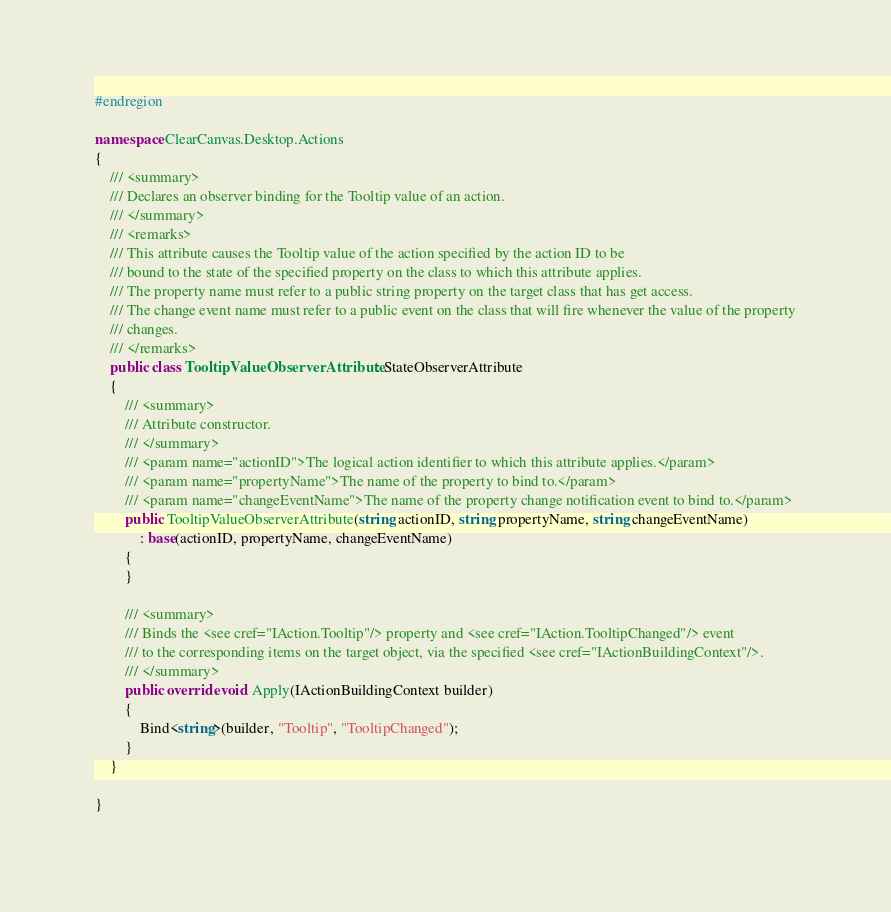Convert code to text. <code><loc_0><loc_0><loc_500><loc_500><_C#_>
#endregion

namespace ClearCanvas.Desktop.Actions
{
	/// <summary>
	/// Declares an observer binding for the Tooltip value of an action.
	/// </summary>
	/// <remarks>
	/// This attribute causes the Tooltip value of the action specified by the action ID to be
	/// bound to the state of the specified property on the class to which this attribute applies.
	/// The property name must refer to a public string property on the target class that has get access.
	/// The change event name must refer to a public event on the class that will fire whenever the value of the property
	/// changes.
	/// </remarks>
	public class TooltipValueObserverAttribute : StateObserverAttribute
	{
		/// <summary>
		/// Attribute constructor.
		/// </summary>
		/// <param name="actionID">The logical action identifier to which this attribute applies.</param>
		/// <param name="propertyName">The name of the property to bind to.</param>
		/// <param name="changeEventName">The name of the property change notification event to bind to.</param>
		public TooltipValueObserverAttribute(string actionID, string propertyName, string changeEventName)
			: base(actionID, propertyName, changeEventName)
		{
		}

		/// <summary>
		/// Binds the <see cref="IAction.Tooltip"/> property and <see cref="IAction.TooltipChanged"/> event 
		/// to the corresponding items on the target object, via the specified <see cref="IActionBuildingContext"/>.
		/// </summary>
		public override void Apply(IActionBuildingContext builder)
		{
            Bind<string>(builder, "Tooltip", "TooltipChanged");
        }
	}

}
</code> 